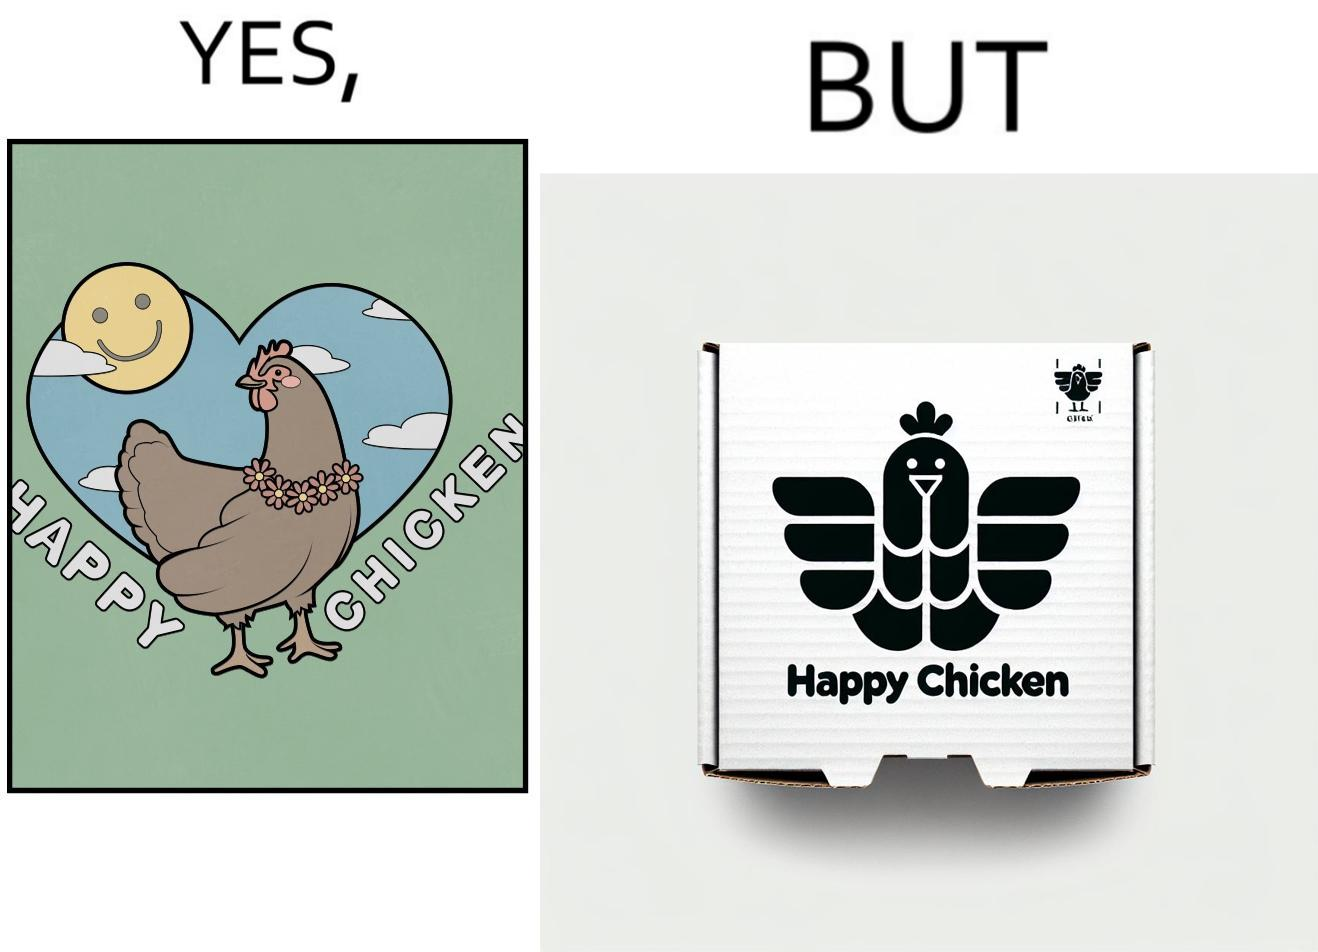Describe what you see in the left and right parts of this image. In the left part of the image: a chicken with a quote "HAPPY CHICKEN" in the background In the right part of the image: chicken pieces packed in boxes with a logo of a chicken with name "HAPPY CHICKEN" printed on it 